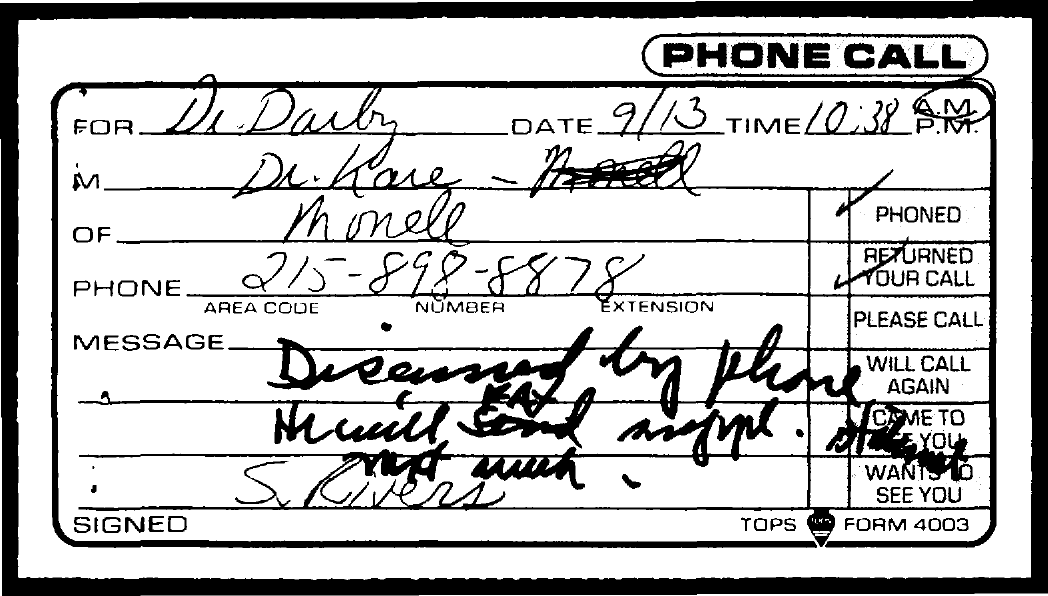What is the date mentioned in the document?
Provide a succinct answer. 9/13. What is the area code?
Make the answer very short. 215. 